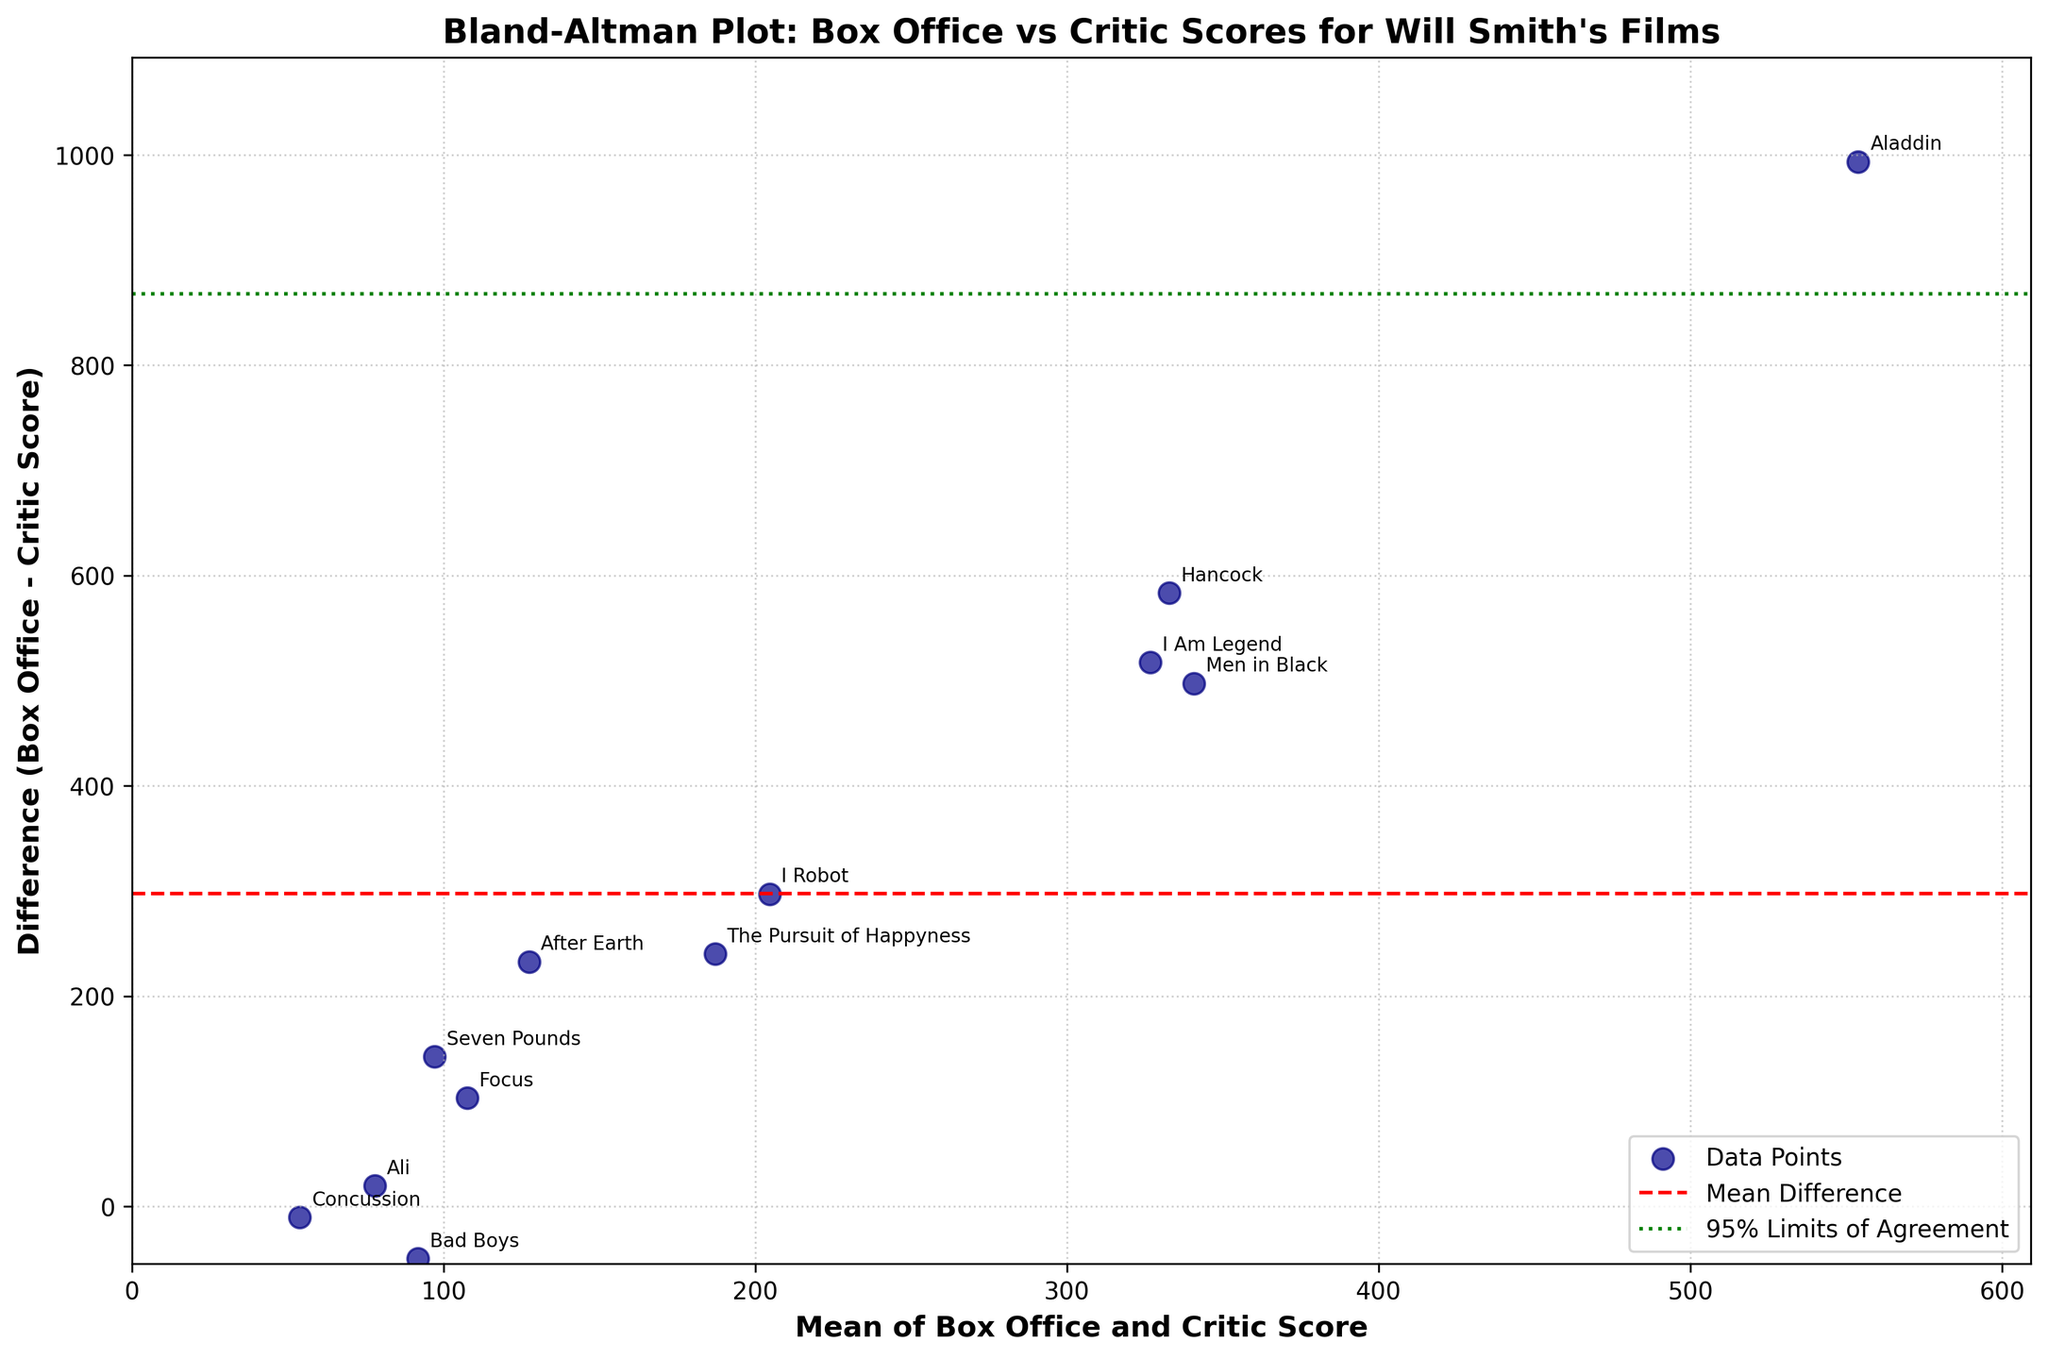How many data points are plotted on the figure? Count the number of data points (or movies) labeled in the scatterplot.
Answer: 12 What is the title of the figure? Read the title at the top of the figure.
Answer: Bland-Altman Plot: Box Office vs Critic Scores for Will Smith's Films What are the axes labels in the figure? Read the labels on the x-axis and y-axis.
Answer: x-axis: Mean of Box Office and Critic Score, y-axis: Difference (Box Office - Critic Score) Which movie has the highest box office earnings versus critic score difference? Identify the movie with the highest point on the y-axis.
Answer: Aladdin What does the red dashed line represent in the plot? Identify the horizontal red dashed line and its label.
Answer: Mean Difference Which movies have a negative difference between box office earnings and critic scores? Look for data points below the y=0 line and read their labels.
Answer: Bad Boys, Concussion Which movie has the mean of box office earnings and critic score closest to 100? Identify the point closest to x=100, and read its label.
Answer: Concussion Which movie pairs have the highest differences, and what are they? Identify the two highest points on the y-axis and read their labels.
Answer: Aladdin (993.7) and Hancock (583.4) What are the green dotted lines representing in this Bland–Altman plot? Identify the green dotted lines and read their labels.
Answer: 95% Limits of Agreement Which movie has the smallest difference between its box office earnings and critic score? Identify the point closest to y=0 and read its label.
Answer: Concussion 